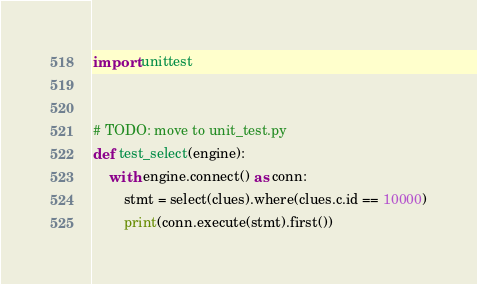<code> <loc_0><loc_0><loc_500><loc_500><_Python_>import unittest


# TODO: move to unit_test.py
def test_select(engine):
    with engine.connect() as conn:
        stmt = select(clues).where(clues.c.id == 10000)
        print(conn.execute(stmt).first())</code> 